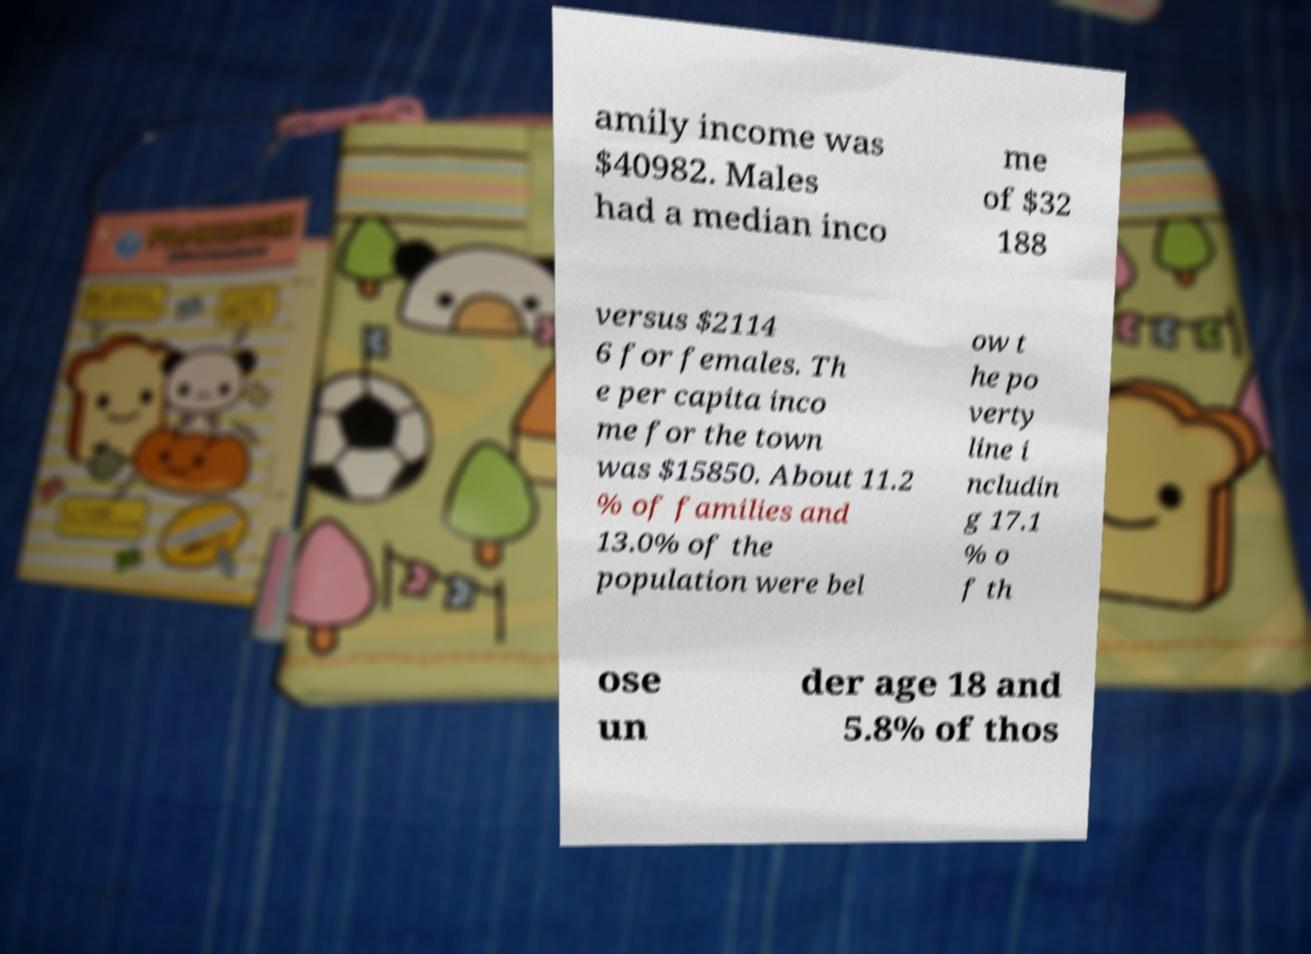Can you accurately transcribe the text from the provided image for me? amily income was $40982. Males had a median inco me of $32 188 versus $2114 6 for females. Th e per capita inco me for the town was $15850. About 11.2 % of families and 13.0% of the population were bel ow t he po verty line i ncludin g 17.1 % o f th ose un der age 18 and 5.8% of thos 